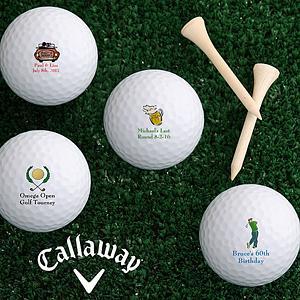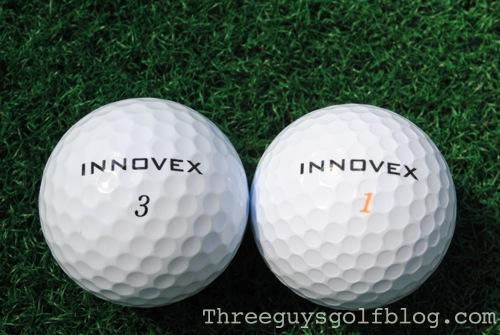The first image is the image on the left, the second image is the image on the right. Analyze the images presented: Is the assertion "The balls in at least one of the images are set on the grass." valid? Answer yes or no. Yes. 